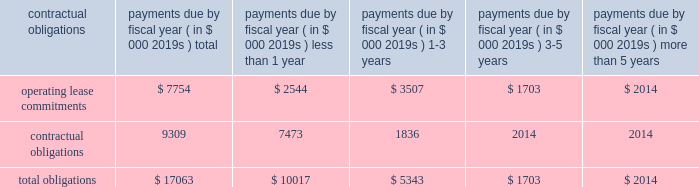97% ( 97 % ) of its carrying value .
The columbia fund is being liquidated with distributions to us occurring and expected to be fully liquidated during calendar 2008 .
Since december 2007 , we have received disbursements of approximately $ 20.7 million from the columbia fund .
Our operating activities during the year ended march 31 , 2008 used cash of $ 28.9 million as compared to $ 19.8 million during the same period in the prior year .
Our fiscal 2008 net loss of $ 40.9 million was the primary cause of our cash use from operations , attributed to increased investments in our global distribution as we continue to drive initiatives to increase recovery awareness as well as our investments in research and development to broaden our circulatory care product portfolio .
In addition , our inventories used cash of $ 11.1 million during fiscal 2008 , reflecting our inventory build-up to support anticipated increases in global demand for our products and our accounts receivable also increased as a result of higher sales volume resulting in a use of cash of $ 2.8 million in fiscal 2008 .
These decreases in cash were partially offset by an increase in accounts payable and accrued expenses of $ 5.6 million , non-cash adjustments of $ 5.4 million related to stock-based compensation expense , $ 6.1 million of depreciation and amortization and $ 5.0 million for the change in fair value of worldheart note receivable and warrant .
Our investing activities during the year ended march 31 , 2008 used cash of $ 40.9 million as compared to cash provided by investing activities of $ 15.1 million during the year ended march 31 , 2007 .
Cash used by investment activities for fiscal 2008 consisted primarily of $ 49.3 million for the recharacterization of the columbia fund to short-term marketable securities , $ 17.1 million for the purchase of short-term marketable securities , $ 3.8 million related to expenditures for property and equipment and $ 5.0 million for note receivable advanced to worldheart .
These amounts were offset by $ 34.5 million of proceeds from short-term marketable securities .
In june 2008 , we received 510 ( k ) clearance of our impella 2.5 , triggering an obligation to pay $ 5.6 million of contingent payments in accordance with the may 2005 acquisition of impella .
These contingent payments may be made , at our option , with cash , or stock or by a combination of cash or stock under circumstances described in the purchase agreement .
It is our intent to satisfy this contingent payment through the issuance of shares of our common stock .
Our financing activities during the year ended march 31 , 2008 provided cash of $ 2.1 million as compared to cash provided by financing activities of $ 66.6 million during the same period in the prior year .
Cash provided by financing activities for fiscal 2008 is comprised primarily of $ 2.8 million attributable to the exercise of stock options , $ 0.9 million related to the proceeds from the issuance of common stock , $ 0.3 million related to proceeds from the employee stock purchase plan , partially offset by $ 1.9 million related to the repurchase of warrants .
The $ 64.5 million decrease compared to the prior year is primarily due to $ 63.6 million raised from the public offering in fiscal 2007 .
We disbursed approximately $ 2.2 million of cash for the warrant repurchase and settlement of certain litigation .
Capital expenditures for fiscal 2009 are estimated to be approximately $ 3.0 to $ 6.0 million .
Contractual obligations and commercial commitments the table summarizes our contractual obligations at march 31 , 2008 and the effects such obligations are expected to have on our liquidity and cash flows in future periods .
Payments due by fiscal year ( in $ 000 2019s ) contractual obligations total than 1 than 5 .
We have no long-term debt , capital leases or other material commitments , for open purchase orders and clinical trial agreements at march 31 , 2008 other than those shown in the table above .
In may 2005 , we acquired all the shares of outstanding capital stock of impella cardiosystems ag , a company headquartered in aachen , germany .
The aggregate purchase price excluding a contingent payment in the amount of $ 5.6 million made on january 30 , 2007 in the form of common stock , was approximately $ 45.1 million , which consisted of $ 42.2 million of our common stock , $ 1.6 million of cash paid to certain former shareholders of impella and $ 1.3 million of transaction costs , consisting primarily of fees paid for financial advisory and legal services .
We may make additional contingent payments to impella 2019s former shareholders based on additional milestone payments related to fda approvals in the amount of up to $ 11.2 million .
In june 2008 we received 510 ( k ) clearance of our impella 2.5 , triggering an obligation to pay $ 5.6 million of contingent payments .
These contingent payments may be made , at our option , with cash , or stock or by a combination of cash or stock under circumstances described in the purchase agreement , except that approximately $ 1.8 million of these contingent payments must be made in cash .
The payment of any contingent payments will result in an increase to the carrying value of goodwill .
We apply the disclosure provisions of fin no .
45 , guarantor 2019s accounting and disclosure requirements for guarantees , including guarantees of indebtedness of others , and interpretation of fasb statements no .
5 , 57 and 107 and rescission of fasb interpretation .
What portion of total obligations is related to operating lease commitments as of march 31 , 2008? 
Computations: (7754 / 17063)
Answer: 0.45443. 